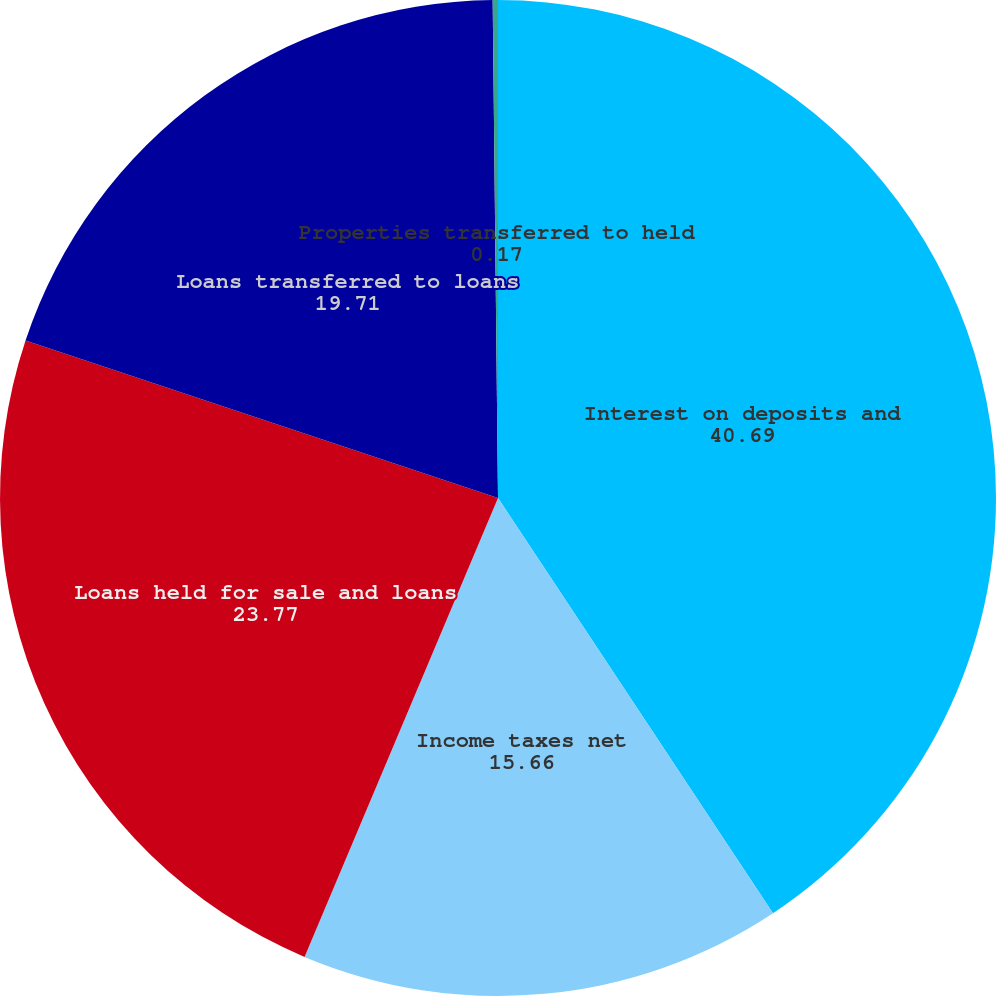Convert chart. <chart><loc_0><loc_0><loc_500><loc_500><pie_chart><fcel>Interest on deposits and<fcel>Income taxes net<fcel>Loans held for sale and loans<fcel>Loans transferred to loans<fcel>Properties transferred to held<nl><fcel>40.69%<fcel>15.66%<fcel>23.77%<fcel>19.71%<fcel>0.17%<nl></chart> 